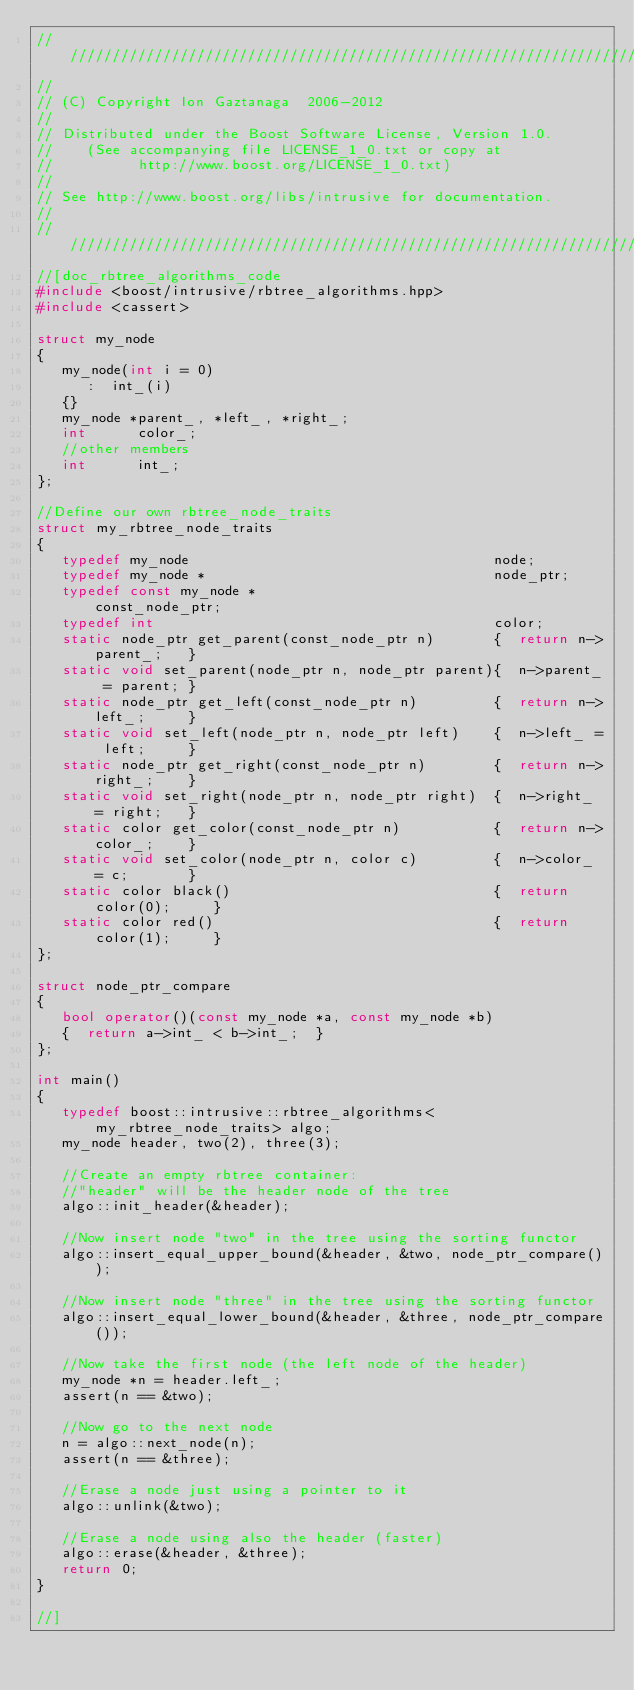<code> <loc_0><loc_0><loc_500><loc_500><_C++_>/////////////////////////////////////////////////////////////////////////////
//
// (C) Copyright Ion Gaztanaga  2006-2012
//
// Distributed under the Boost Software License, Version 1.0.
//    (See accompanying file LICENSE_1_0.txt or copy at
//          http://www.boost.org/LICENSE_1_0.txt)
//
// See http://www.boost.org/libs/intrusive for documentation.
//
/////////////////////////////////////////////////////////////////////////////
//[doc_rbtree_algorithms_code
#include <boost/intrusive/rbtree_algorithms.hpp>
#include <cassert>

struct my_node
{
   my_node(int i = 0)
      :  int_(i)
   {}
   my_node *parent_, *left_, *right_;
   int      color_;
   //other members
   int      int_;
};

//Define our own rbtree_node_traits
struct my_rbtree_node_traits
{
   typedef my_node                                    node;
   typedef my_node *                                  node_ptr;
   typedef const my_node *                            const_node_ptr;
   typedef int                                        color;
   static node_ptr get_parent(const_node_ptr n)       {  return n->parent_;   }
   static void set_parent(node_ptr n, node_ptr parent){  n->parent_ = parent; }
   static node_ptr get_left(const_node_ptr n)         {  return n->left_;     }
   static void set_left(node_ptr n, node_ptr left)    {  n->left_ = left;     }
   static node_ptr get_right(const_node_ptr n)        {  return n->right_;    }
   static void set_right(node_ptr n, node_ptr right)  {  n->right_ = right;   }
   static color get_color(const_node_ptr n)           {  return n->color_;    }
   static void set_color(node_ptr n, color c)         {  n->color_ = c;       }
   static color black()                               {  return color(0);     }
   static color red()                                 {  return color(1);     }
};

struct node_ptr_compare
{
   bool operator()(const my_node *a, const my_node *b)
   {  return a->int_ < b->int_;  }
};

int main()
{
   typedef boost::intrusive::rbtree_algorithms<my_rbtree_node_traits> algo;
   my_node header, two(2), three(3);

   //Create an empty rbtree container:
   //"header" will be the header node of the tree
   algo::init_header(&header);

   //Now insert node "two" in the tree using the sorting functor
   algo::insert_equal_upper_bound(&header, &two, node_ptr_compare());

   //Now insert node "three" in the tree using the sorting functor
   algo::insert_equal_lower_bound(&header, &three, node_ptr_compare());

   //Now take the first node (the left node of the header)
   my_node *n = header.left_;
   assert(n == &two);

   //Now go to the next node
   n = algo::next_node(n);
   assert(n == &three);

   //Erase a node just using a pointer to it
   algo::unlink(&two);

   //Erase a node using also the header (faster)
   algo::erase(&header, &three);
   return 0;
}

//]
</code> 